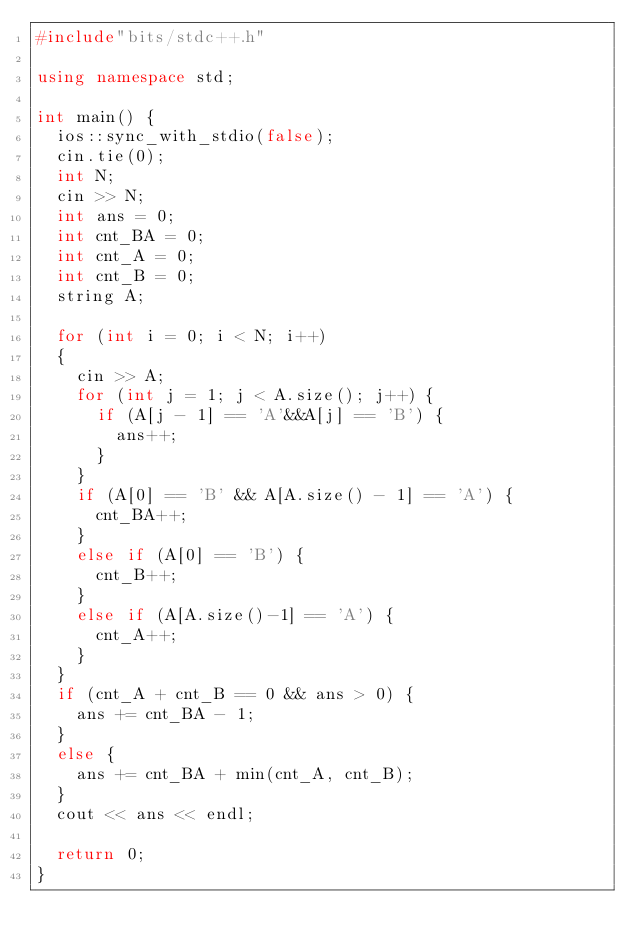Convert code to text. <code><loc_0><loc_0><loc_500><loc_500><_C++_>#include"bits/stdc++.h"

using namespace std;

int main() {
	ios::sync_with_stdio(false);
	cin.tie(0);
	int N;
	cin >> N;
	int ans = 0;
	int cnt_BA = 0;
	int cnt_A = 0;
	int cnt_B = 0;
	string A;

	for (int i = 0; i < N; i++)
	{
		cin >> A;
		for (int j = 1; j < A.size(); j++) {
			if (A[j - 1] == 'A'&&A[j] == 'B') {
				ans++;
			}
		}
		if (A[0] == 'B' && A[A.size() - 1] == 'A') {
			cnt_BA++;
		}
		else if (A[0] == 'B') {
			cnt_B++;
		}
		else if (A[A.size()-1] == 'A') {
			cnt_A++;
		}
	}
	if (cnt_A + cnt_B == 0 && ans > 0) {
		ans += cnt_BA - 1;
	}
	else {
		ans += cnt_BA + min(cnt_A, cnt_B);
	}
	cout << ans << endl;

	return 0;
}</code> 